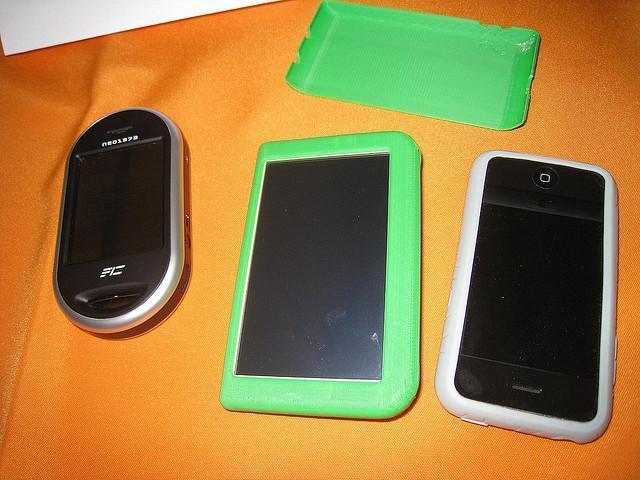How many cell phones are there?
Give a very brief answer. 3. 